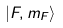<formula> <loc_0><loc_0><loc_500><loc_500>| F , m _ { F } \rangle</formula> 